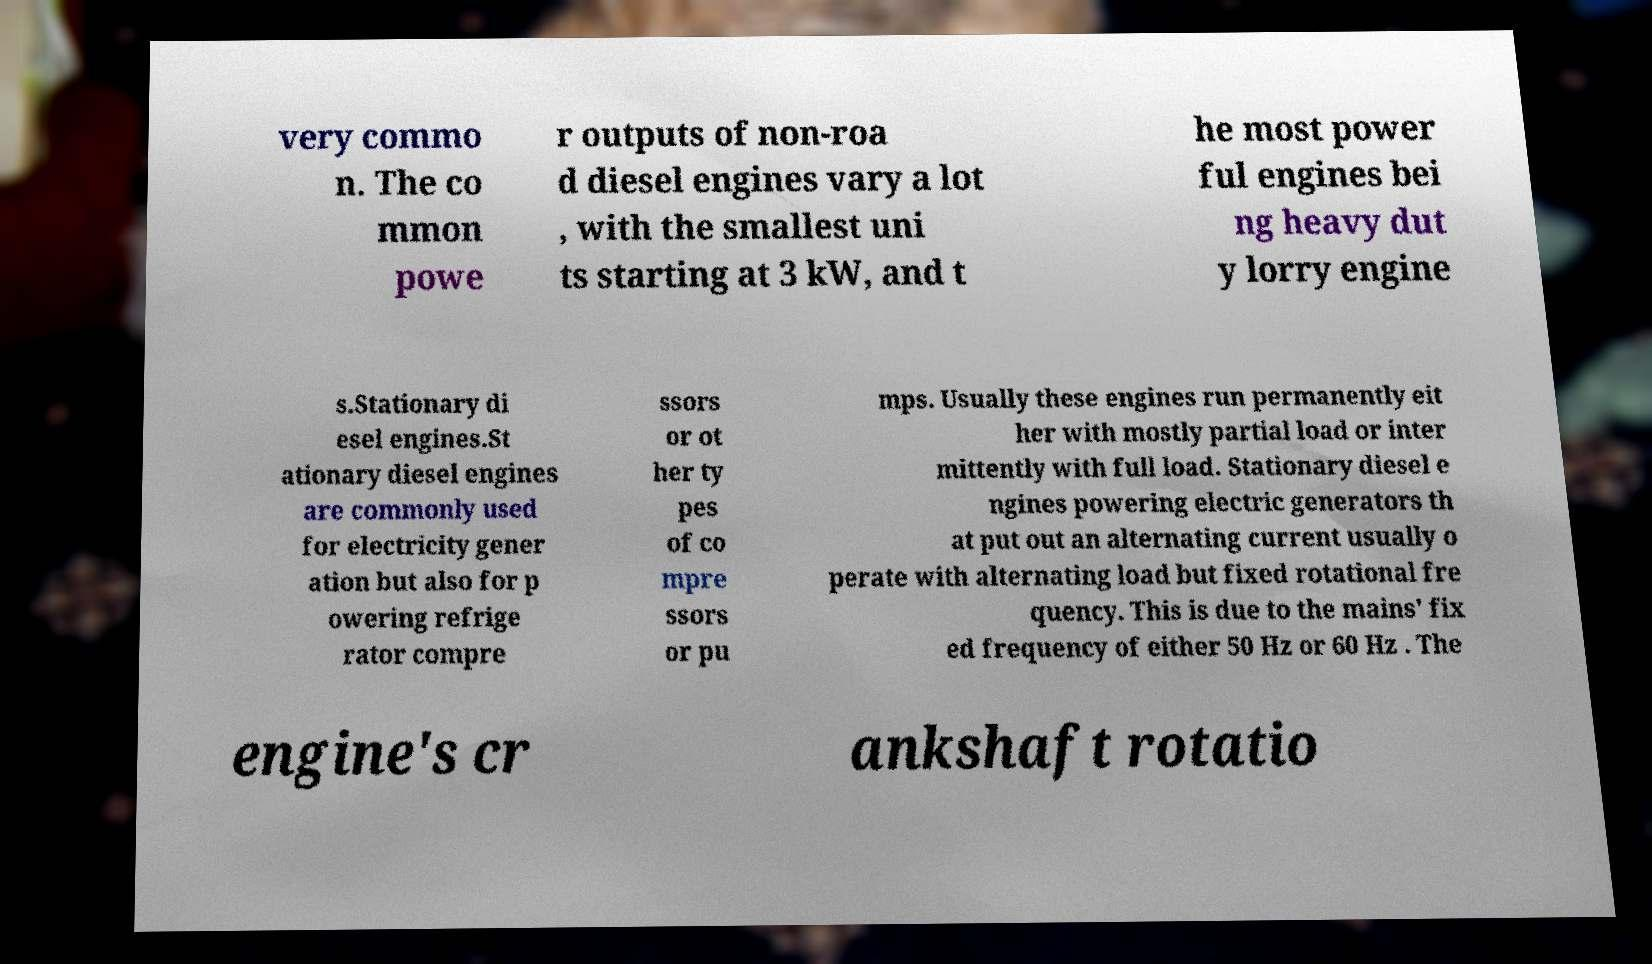Please identify and transcribe the text found in this image. very commo n. The co mmon powe r outputs of non-roa d diesel engines vary a lot , with the smallest uni ts starting at 3 kW, and t he most power ful engines bei ng heavy dut y lorry engine s.Stationary di esel engines.St ationary diesel engines are commonly used for electricity gener ation but also for p owering refrige rator compre ssors or ot her ty pes of co mpre ssors or pu mps. Usually these engines run permanently eit her with mostly partial load or inter mittently with full load. Stationary diesel e ngines powering electric generators th at put out an alternating current usually o perate with alternating load but fixed rotational fre quency. This is due to the mains' fix ed frequency of either 50 Hz or 60 Hz . The engine's cr ankshaft rotatio 